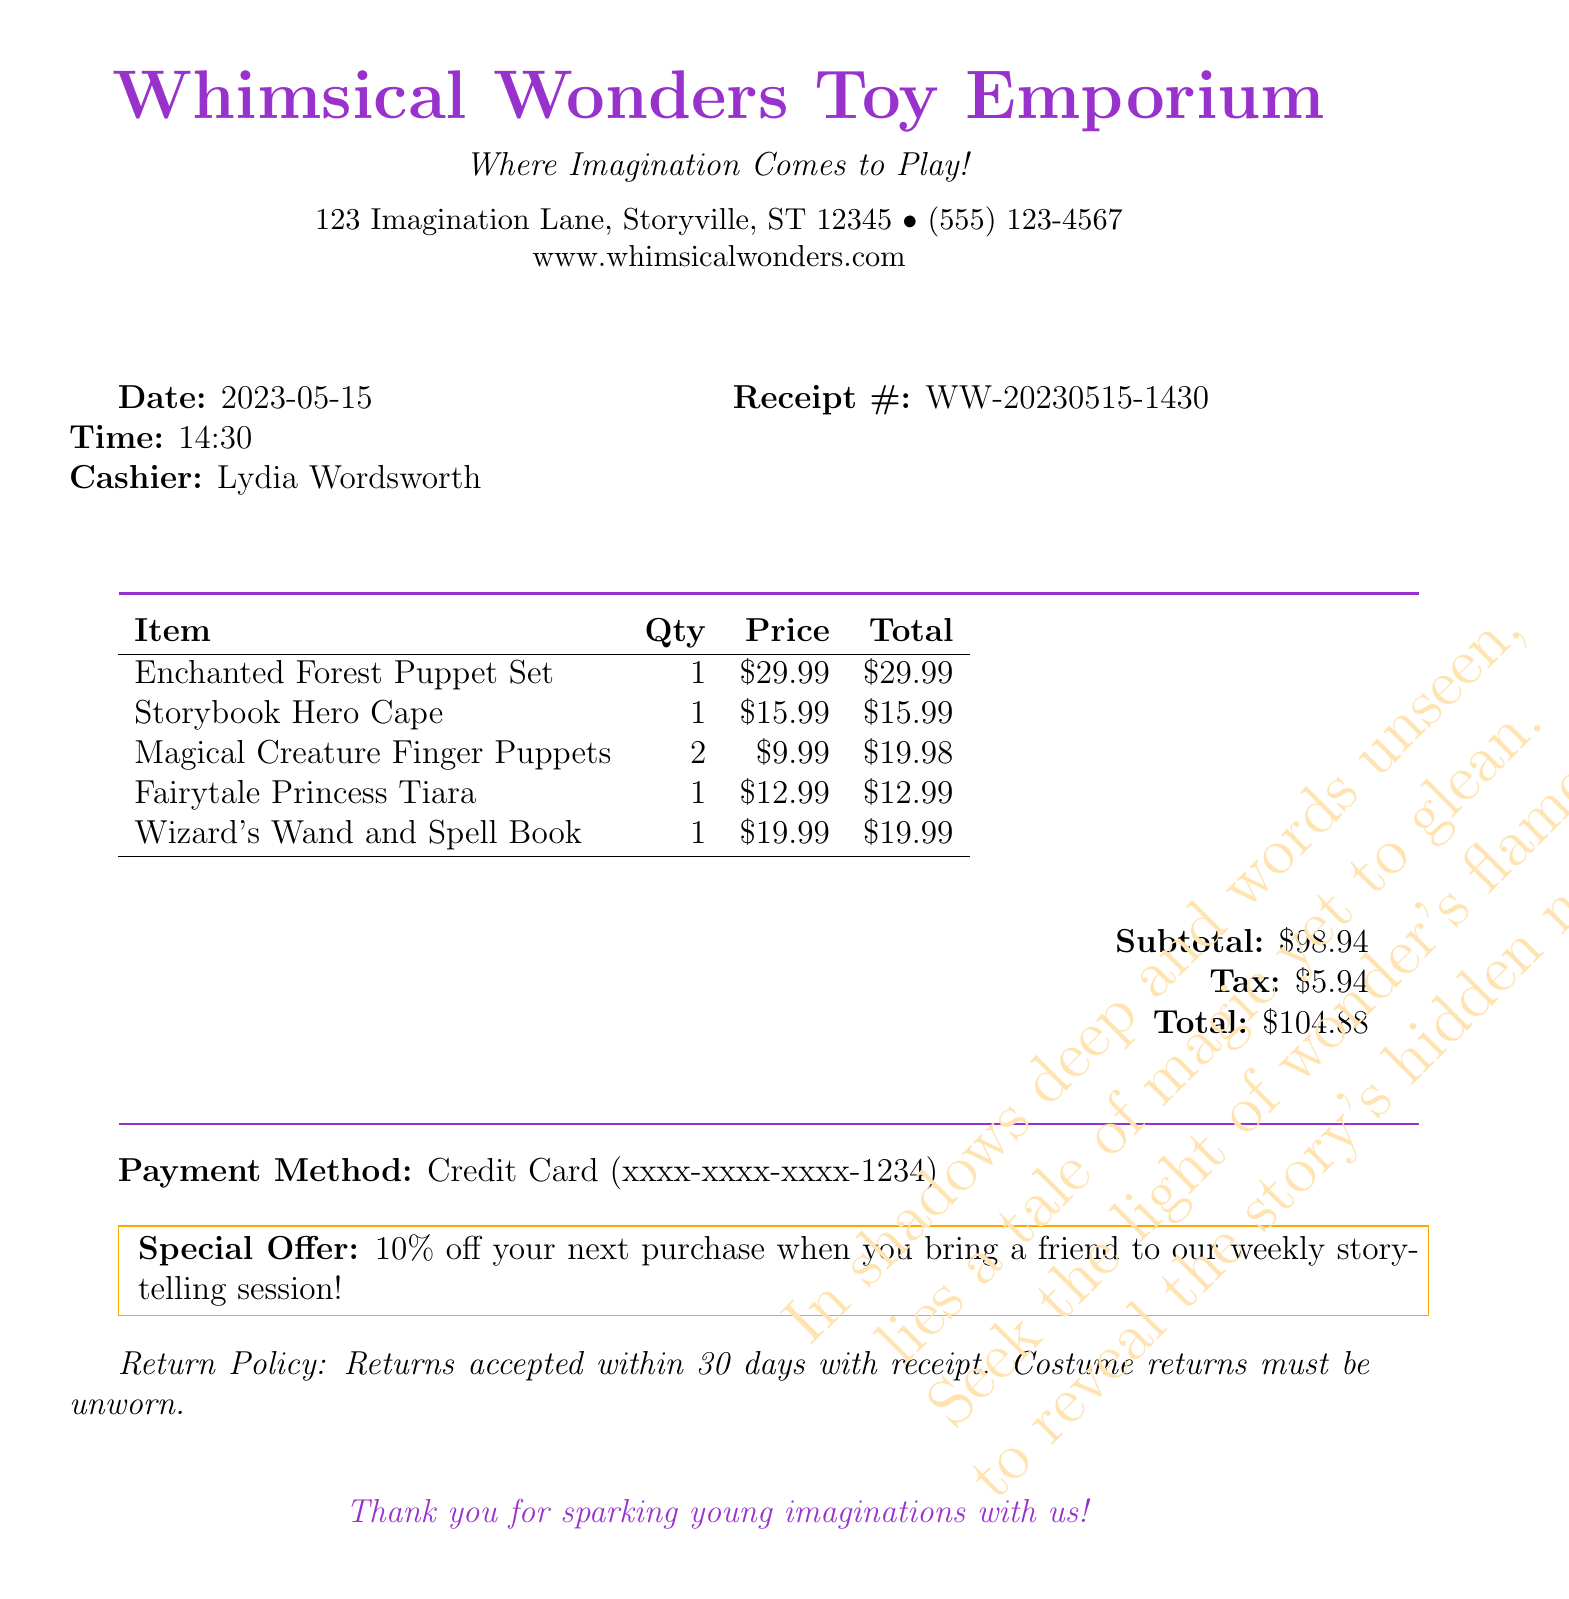What is the name of the store? The name of the store is prominently displayed at the top of the receipt.
Answer: Whimsical Wonders Toy Emporium What is the date of the purchase? The date is clearly labeled after the store information on the receipt.
Answer: 2023-05-15 Who was the cashier? The cashier's name is mentioned next to the cashier label on the receipt.
Answer: Lydia Wordsworth What is the subtotal amount? The subtotal is indicated near the total summary at the bottom of the receipt.
Answer: $98.94 How many items are there in total? The total number of unique items listed in the items section of the receipt must be counted.
Answer: 5 What is the special offer? The special offer is explicitly detailed within a boxed section on the receipt.
Answer: 10% off your next purchase What is the total cost after tax? The total cost is provided after the subtotal and tax calculations at the bottom of the receipt.
Answer: $104.88 What is the return policy timeframe? The return policy is stated clearly on the receipt regarding item returns.
Answer: 30 days What rhyme is mentioned in invisible ink? The hidden riddle is a whimsical addition noted in the document.
Answer: In shadows deep and words unseen, lies a tale of magic yet to glean. Seek the light of wonder's flame, to reveal the story's hidden name 